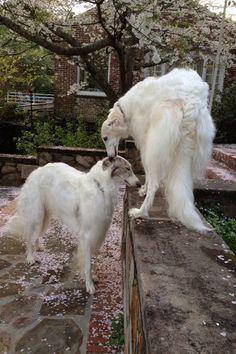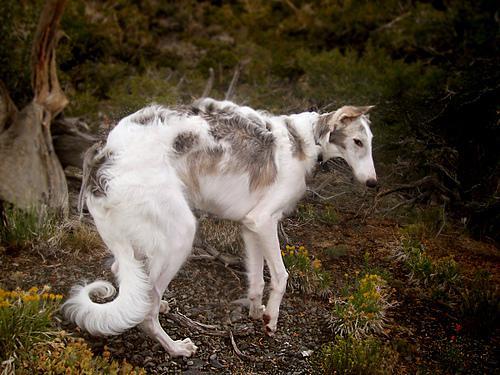The first image is the image on the left, the second image is the image on the right. Evaluate the accuracy of this statement regarding the images: "A person is standing in the center of the scene, interacting with at least one all-white dog.". Is it true? Answer yes or no. No. The first image is the image on the left, the second image is the image on the right. Assess this claim about the two images: "A dog is being touched by a human in one of the images.". Correct or not? Answer yes or no. No. 